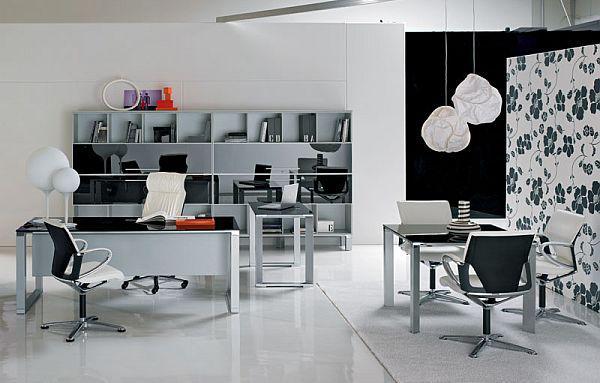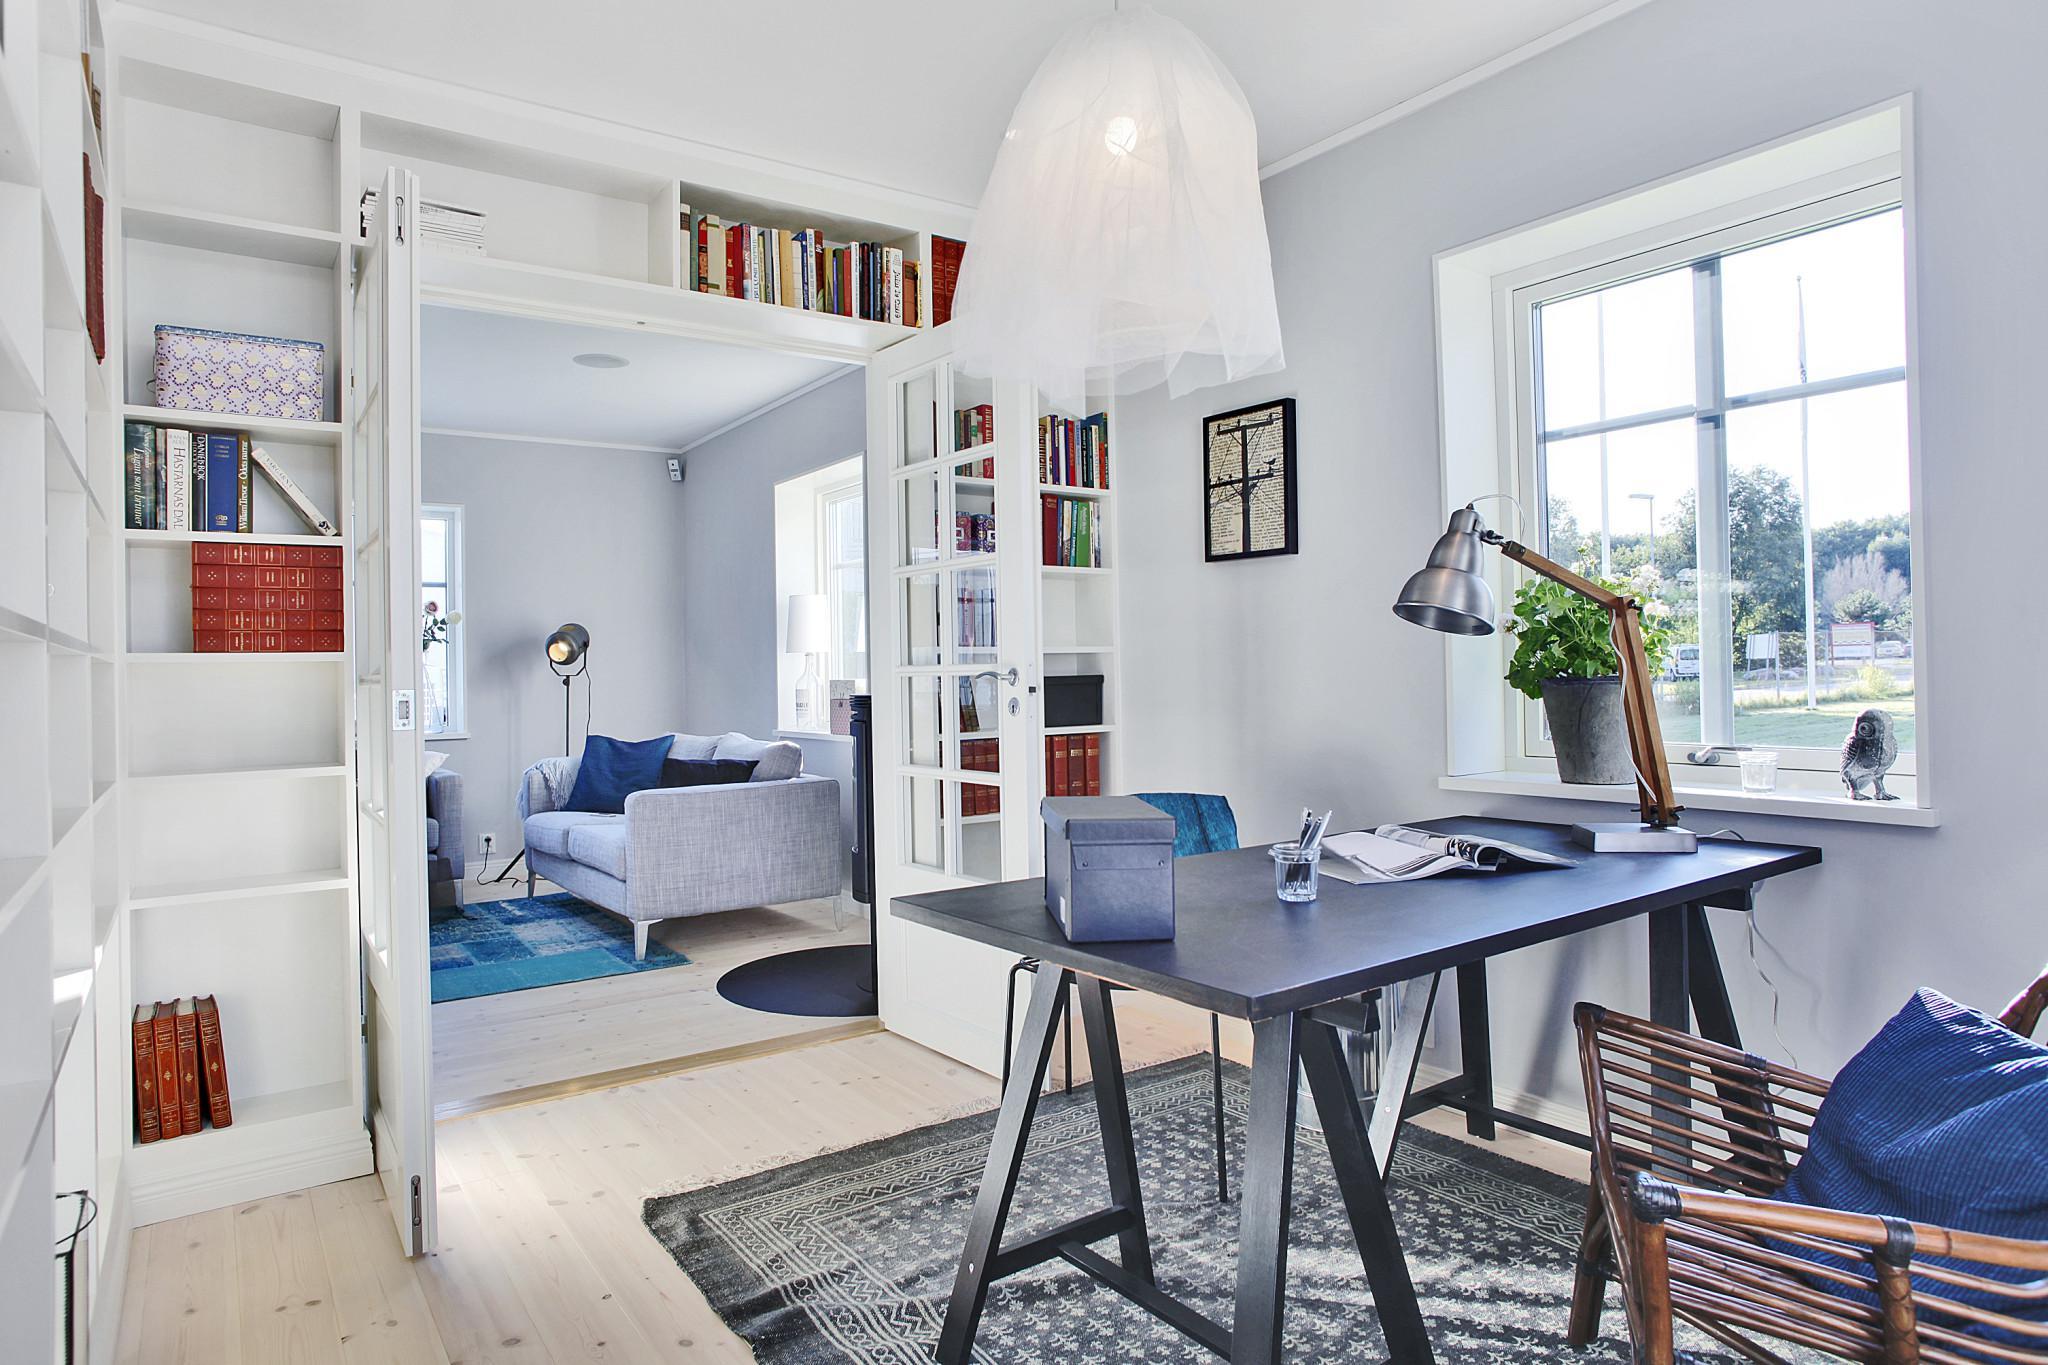The first image is the image on the left, the second image is the image on the right. For the images shown, is this caption "At least one desk has a white surface." true? Answer yes or no. No. 